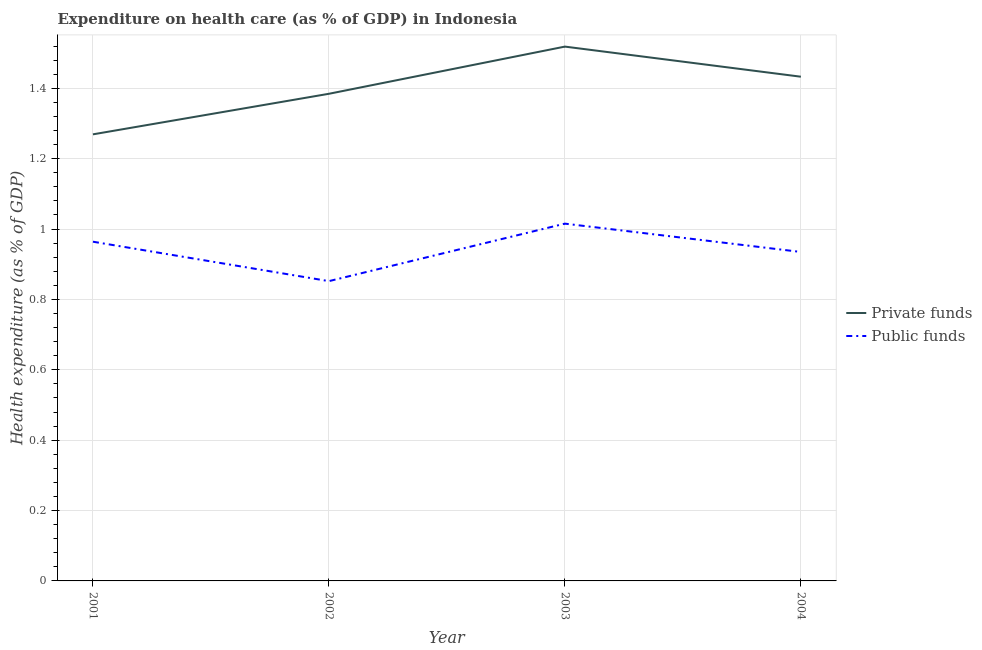What is the amount of private funds spent in healthcare in 2002?
Ensure brevity in your answer.  1.38. Across all years, what is the maximum amount of private funds spent in healthcare?
Your answer should be very brief. 1.52. Across all years, what is the minimum amount of public funds spent in healthcare?
Keep it short and to the point. 0.85. In which year was the amount of private funds spent in healthcare maximum?
Offer a very short reply. 2003. What is the total amount of public funds spent in healthcare in the graph?
Keep it short and to the point. 3.77. What is the difference between the amount of public funds spent in healthcare in 2001 and that in 2004?
Provide a short and direct response. 0.03. What is the difference between the amount of private funds spent in healthcare in 2002 and the amount of public funds spent in healthcare in 2001?
Offer a terse response. 0.42. What is the average amount of private funds spent in healthcare per year?
Offer a terse response. 1.4. In the year 2004, what is the difference between the amount of public funds spent in healthcare and amount of private funds spent in healthcare?
Keep it short and to the point. -0.5. What is the ratio of the amount of private funds spent in healthcare in 2003 to that in 2004?
Provide a short and direct response. 1.06. Is the amount of private funds spent in healthcare in 2003 less than that in 2004?
Keep it short and to the point. No. Is the difference between the amount of private funds spent in healthcare in 2002 and 2004 greater than the difference between the amount of public funds spent in healthcare in 2002 and 2004?
Offer a terse response. Yes. What is the difference between the highest and the second highest amount of public funds spent in healthcare?
Give a very brief answer. 0.05. What is the difference between the highest and the lowest amount of public funds spent in healthcare?
Your answer should be compact. 0.16. Is the sum of the amount of private funds spent in healthcare in 2001 and 2003 greater than the maximum amount of public funds spent in healthcare across all years?
Make the answer very short. Yes. Does the amount of public funds spent in healthcare monotonically increase over the years?
Offer a very short reply. No. Is the amount of public funds spent in healthcare strictly greater than the amount of private funds spent in healthcare over the years?
Ensure brevity in your answer.  No. Are the values on the major ticks of Y-axis written in scientific E-notation?
Your answer should be very brief. No. Does the graph contain grids?
Offer a very short reply. Yes. How are the legend labels stacked?
Offer a terse response. Vertical. What is the title of the graph?
Make the answer very short. Expenditure on health care (as % of GDP) in Indonesia. What is the label or title of the Y-axis?
Your answer should be very brief. Health expenditure (as % of GDP). What is the Health expenditure (as % of GDP) in Private funds in 2001?
Give a very brief answer. 1.27. What is the Health expenditure (as % of GDP) in Public funds in 2001?
Offer a very short reply. 0.96. What is the Health expenditure (as % of GDP) of Private funds in 2002?
Make the answer very short. 1.38. What is the Health expenditure (as % of GDP) of Public funds in 2002?
Your answer should be very brief. 0.85. What is the Health expenditure (as % of GDP) of Private funds in 2003?
Ensure brevity in your answer.  1.52. What is the Health expenditure (as % of GDP) of Public funds in 2003?
Your answer should be very brief. 1.02. What is the Health expenditure (as % of GDP) of Private funds in 2004?
Offer a very short reply. 1.43. What is the Health expenditure (as % of GDP) of Public funds in 2004?
Your answer should be compact. 0.93. Across all years, what is the maximum Health expenditure (as % of GDP) in Private funds?
Your answer should be compact. 1.52. Across all years, what is the maximum Health expenditure (as % of GDP) of Public funds?
Keep it short and to the point. 1.02. Across all years, what is the minimum Health expenditure (as % of GDP) of Private funds?
Offer a terse response. 1.27. Across all years, what is the minimum Health expenditure (as % of GDP) in Public funds?
Your answer should be very brief. 0.85. What is the total Health expenditure (as % of GDP) in Private funds in the graph?
Provide a succinct answer. 5.6. What is the total Health expenditure (as % of GDP) in Public funds in the graph?
Your response must be concise. 3.77. What is the difference between the Health expenditure (as % of GDP) of Private funds in 2001 and that in 2002?
Your answer should be compact. -0.12. What is the difference between the Health expenditure (as % of GDP) in Public funds in 2001 and that in 2002?
Your answer should be very brief. 0.11. What is the difference between the Health expenditure (as % of GDP) in Private funds in 2001 and that in 2003?
Your answer should be compact. -0.25. What is the difference between the Health expenditure (as % of GDP) in Public funds in 2001 and that in 2003?
Provide a succinct answer. -0.05. What is the difference between the Health expenditure (as % of GDP) in Private funds in 2001 and that in 2004?
Offer a terse response. -0.16. What is the difference between the Health expenditure (as % of GDP) in Public funds in 2001 and that in 2004?
Provide a short and direct response. 0.03. What is the difference between the Health expenditure (as % of GDP) of Private funds in 2002 and that in 2003?
Keep it short and to the point. -0.13. What is the difference between the Health expenditure (as % of GDP) in Public funds in 2002 and that in 2003?
Provide a short and direct response. -0.16. What is the difference between the Health expenditure (as % of GDP) in Private funds in 2002 and that in 2004?
Your response must be concise. -0.05. What is the difference between the Health expenditure (as % of GDP) in Public funds in 2002 and that in 2004?
Make the answer very short. -0.08. What is the difference between the Health expenditure (as % of GDP) of Private funds in 2003 and that in 2004?
Provide a succinct answer. 0.09. What is the difference between the Health expenditure (as % of GDP) in Public funds in 2003 and that in 2004?
Your answer should be very brief. 0.08. What is the difference between the Health expenditure (as % of GDP) in Private funds in 2001 and the Health expenditure (as % of GDP) in Public funds in 2002?
Offer a terse response. 0.42. What is the difference between the Health expenditure (as % of GDP) of Private funds in 2001 and the Health expenditure (as % of GDP) of Public funds in 2003?
Provide a succinct answer. 0.25. What is the difference between the Health expenditure (as % of GDP) of Private funds in 2001 and the Health expenditure (as % of GDP) of Public funds in 2004?
Provide a succinct answer. 0.33. What is the difference between the Health expenditure (as % of GDP) in Private funds in 2002 and the Health expenditure (as % of GDP) in Public funds in 2003?
Give a very brief answer. 0.37. What is the difference between the Health expenditure (as % of GDP) in Private funds in 2002 and the Health expenditure (as % of GDP) in Public funds in 2004?
Offer a very short reply. 0.45. What is the difference between the Health expenditure (as % of GDP) in Private funds in 2003 and the Health expenditure (as % of GDP) in Public funds in 2004?
Provide a succinct answer. 0.58. What is the average Health expenditure (as % of GDP) in Private funds per year?
Keep it short and to the point. 1.4. What is the average Health expenditure (as % of GDP) of Public funds per year?
Keep it short and to the point. 0.94. In the year 2001, what is the difference between the Health expenditure (as % of GDP) in Private funds and Health expenditure (as % of GDP) in Public funds?
Your response must be concise. 0.31. In the year 2002, what is the difference between the Health expenditure (as % of GDP) in Private funds and Health expenditure (as % of GDP) in Public funds?
Keep it short and to the point. 0.53. In the year 2003, what is the difference between the Health expenditure (as % of GDP) in Private funds and Health expenditure (as % of GDP) in Public funds?
Give a very brief answer. 0.5. In the year 2004, what is the difference between the Health expenditure (as % of GDP) of Private funds and Health expenditure (as % of GDP) of Public funds?
Provide a succinct answer. 0.5. What is the ratio of the Health expenditure (as % of GDP) of Public funds in 2001 to that in 2002?
Give a very brief answer. 1.13. What is the ratio of the Health expenditure (as % of GDP) in Private funds in 2001 to that in 2003?
Ensure brevity in your answer.  0.84. What is the ratio of the Health expenditure (as % of GDP) in Public funds in 2001 to that in 2003?
Offer a terse response. 0.95. What is the ratio of the Health expenditure (as % of GDP) in Private funds in 2001 to that in 2004?
Give a very brief answer. 0.89. What is the ratio of the Health expenditure (as % of GDP) of Public funds in 2001 to that in 2004?
Your response must be concise. 1.03. What is the ratio of the Health expenditure (as % of GDP) in Private funds in 2002 to that in 2003?
Make the answer very short. 0.91. What is the ratio of the Health expenditure (as % of GDP) in Public funds in 2002 to that in 2003?
Provide a short and direct response. 0.84. What is the ratio of the Health expenditure (as % of GDP) of Private funds in 2002 to that in 2004?
Your answer should be very brief. 0.97. What is the ratio of the Health expenditure (as % of GDP) in Public funds in 2002 to that in 2004?
Ensure brevity in your answer.  0.91. What is the ratio of the Health expenditure (as % of GDP) of Private funds in 2003 to that in 2004?
Give a very brief answer. 1.06. What is the ratio of the Health expenditure (as % of GDP) of Public funds in 2003 to that in 2004?
Provide a succinct answer. 1.09. What is the difference between the highest and the second highest Health expenditure (as % of GDP) of Private funds?
Give a very brief answer. 0.09. What is the difference between the highest and the second highest Health expenditure (as % of GDP) in Public funds?
Give a very brief answer. 0.05. What is the difference between the highest and the lowest Health expenditure (as % of GDP) in Private funds?
Ensure brevity in your answer.  0.25. What is the difference between the highest and the lowest Health expenditure (as % of GDP) in Public funds?
Your answer should be very brief. 0.16. 